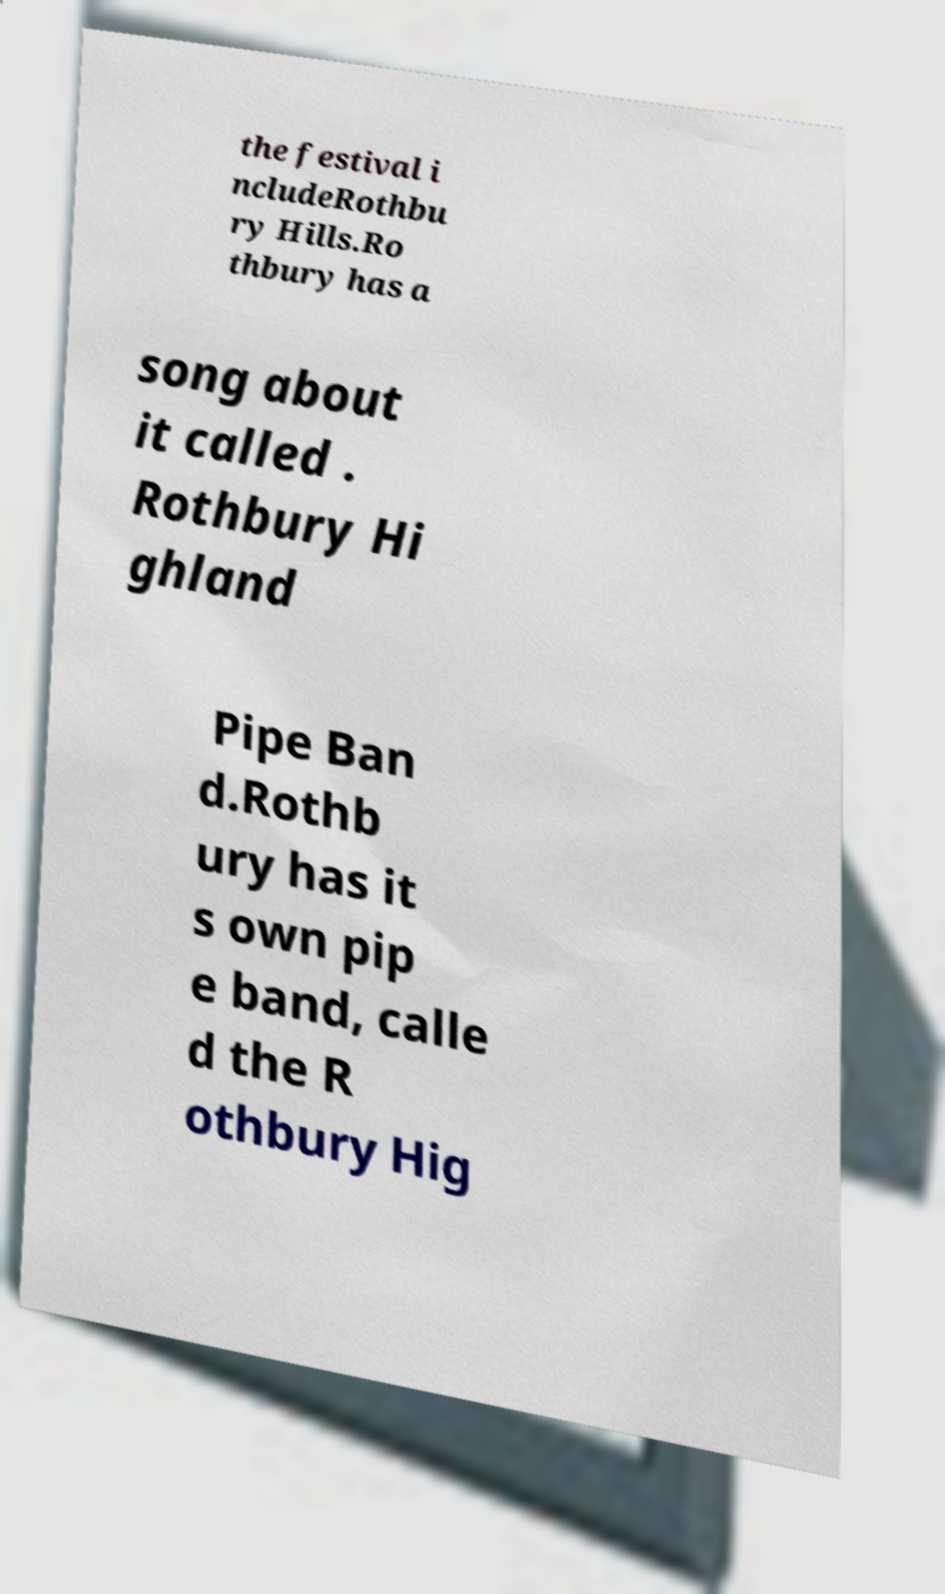Can you accurately transcribe the text from the provided image for me? the festival i ncludeRothbu ry Hills.Ro thbury has a song about it called . Rothbury Hi ghland Pipe Ban d.Rothb ury has it s own pip e band, calle d the R othbury Hig 